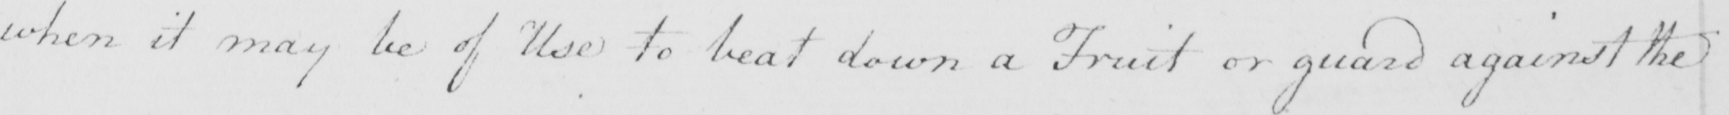What text is written in this handwritten line? when it may be of Use to beat down a Fruit or guard against the 